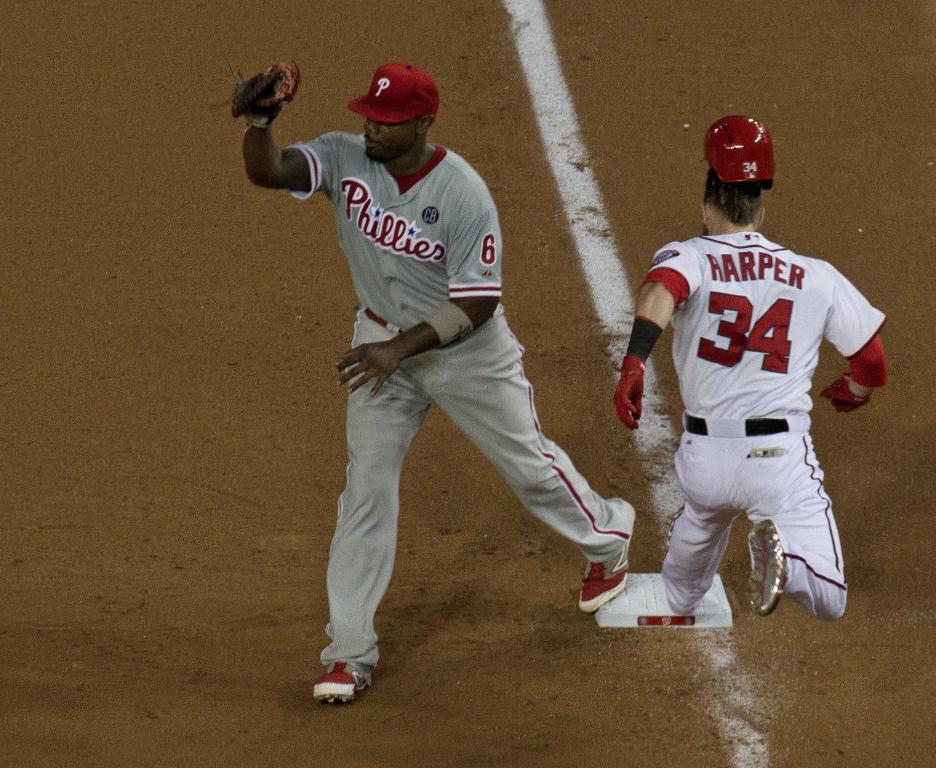What is harper's number?
Your answer should be compact. 34. 